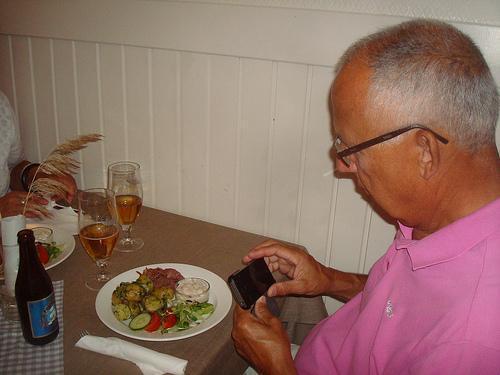How many people can be seen at least partially?
Give a very brief answer. 2. 